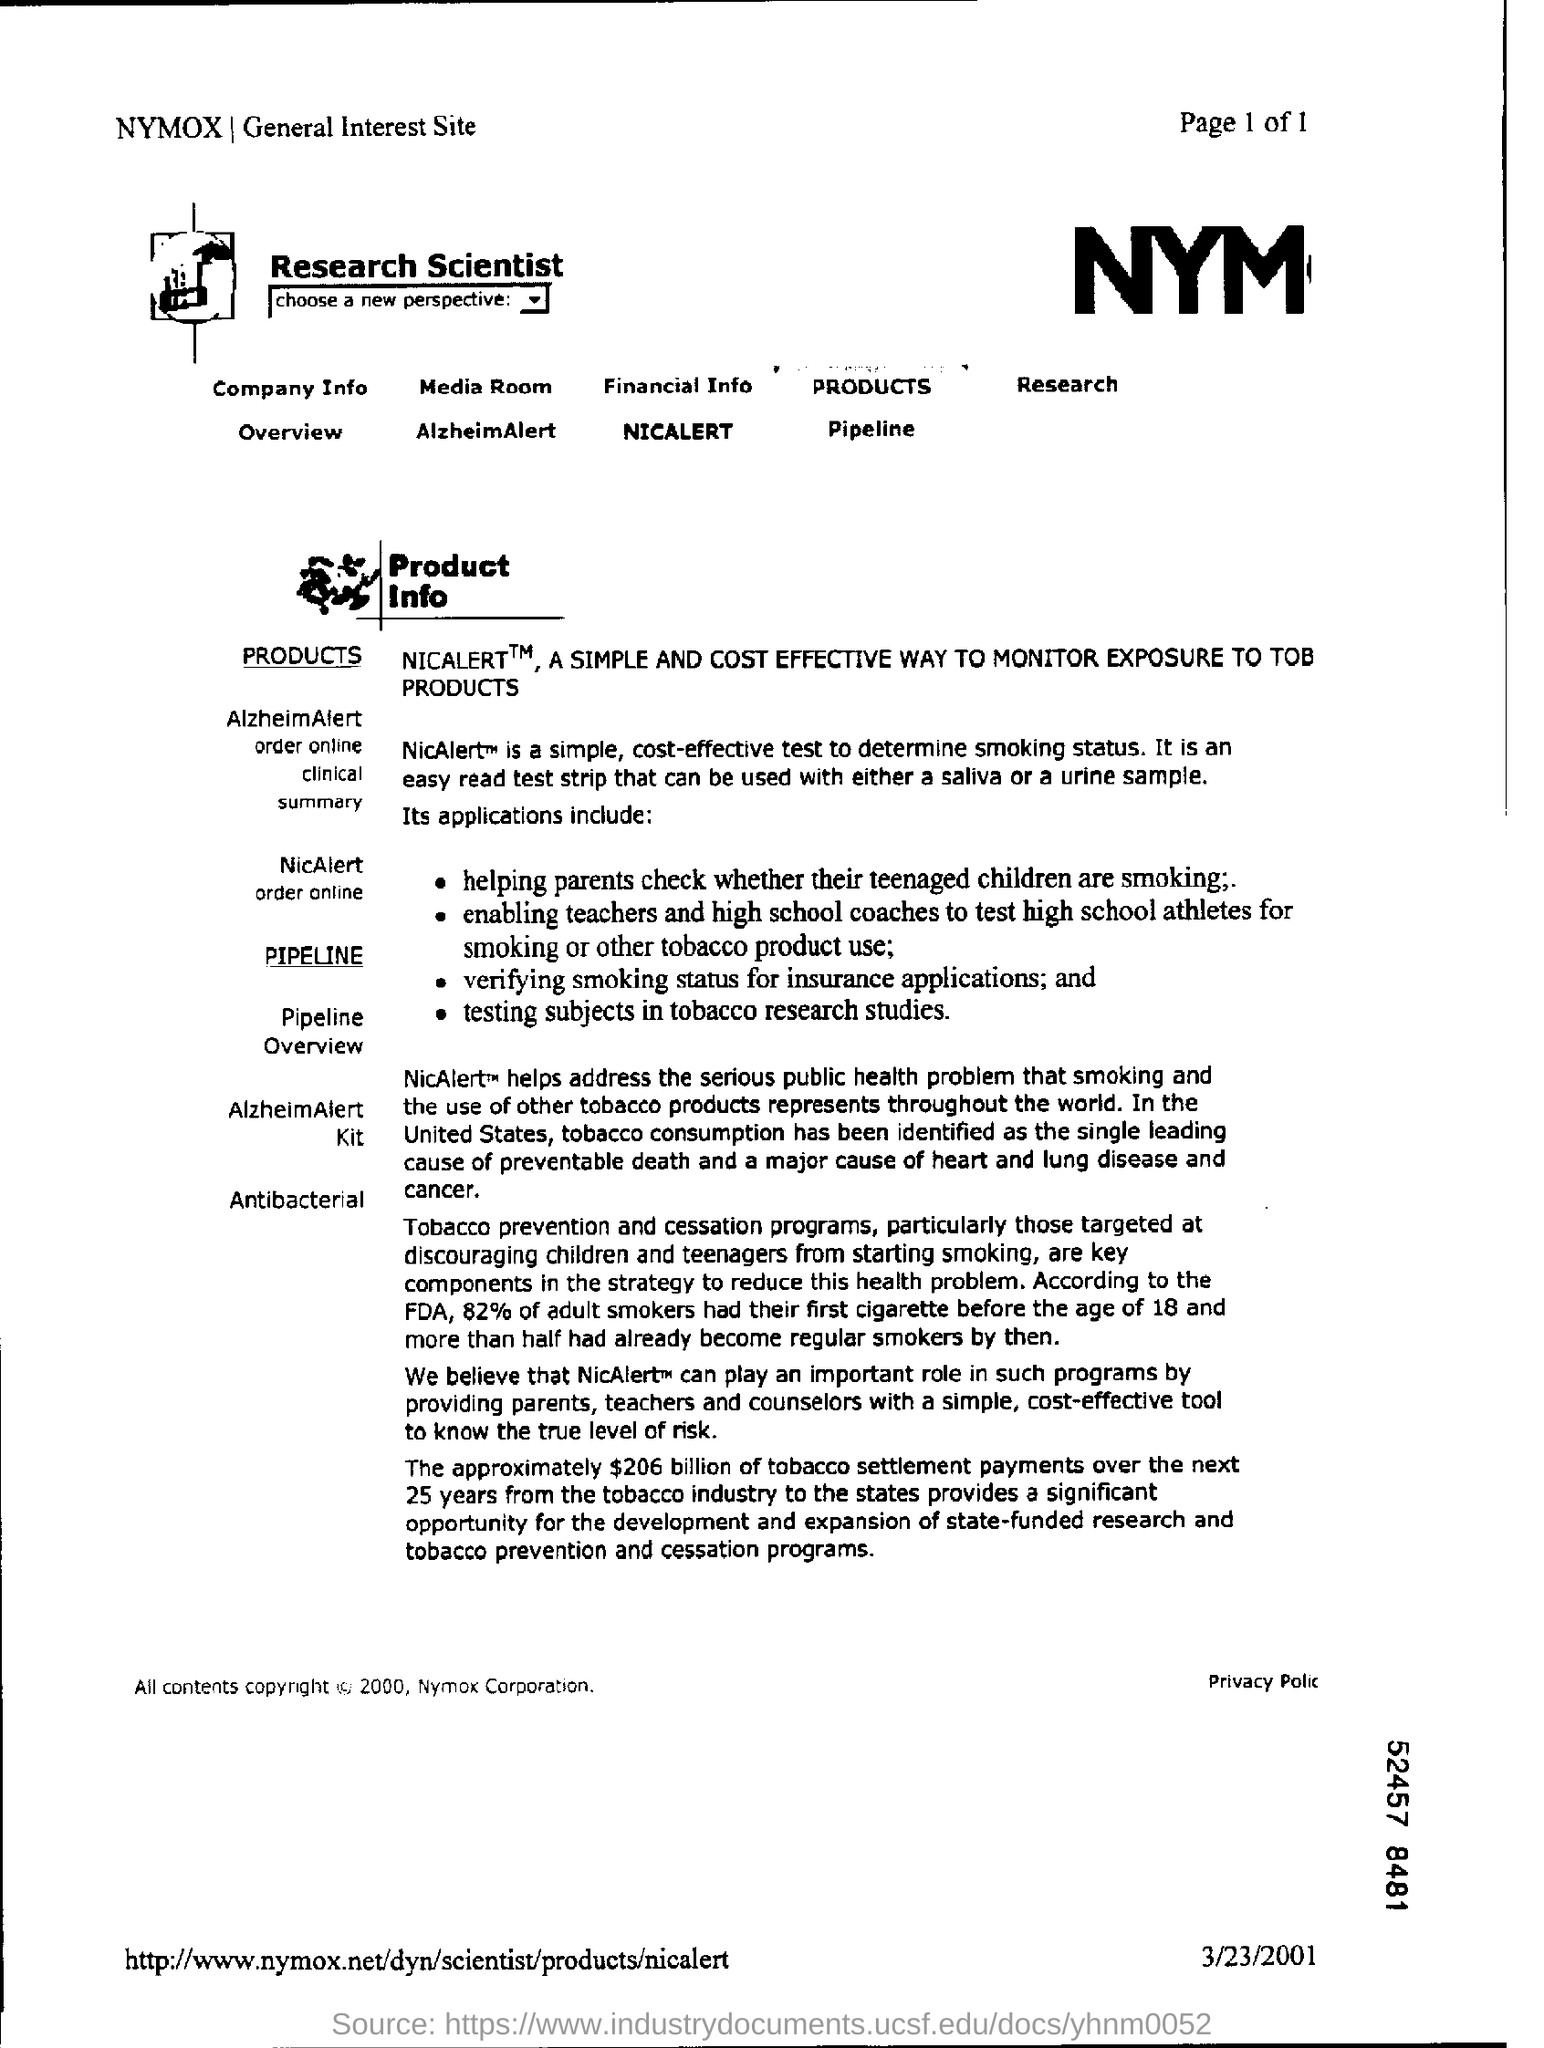Indicate a few pertinent items in this graphic. The FDA reports that 82% of adult smokers began smoking before the age of 18. The approximately $206 billion in tobacco settlement payments from the tobacco industry to the states over the next 25 years presents a significant opportunity for the development of state-funded research and tobacco prevention programs. The top right corner of the page displays a page number of 1 out of 1. According to research, tobacco consumption has been identified as the leading cause of preventable death in the United States. NicAlert is a simple and cost-effective test that can determine a person's smoking status. 